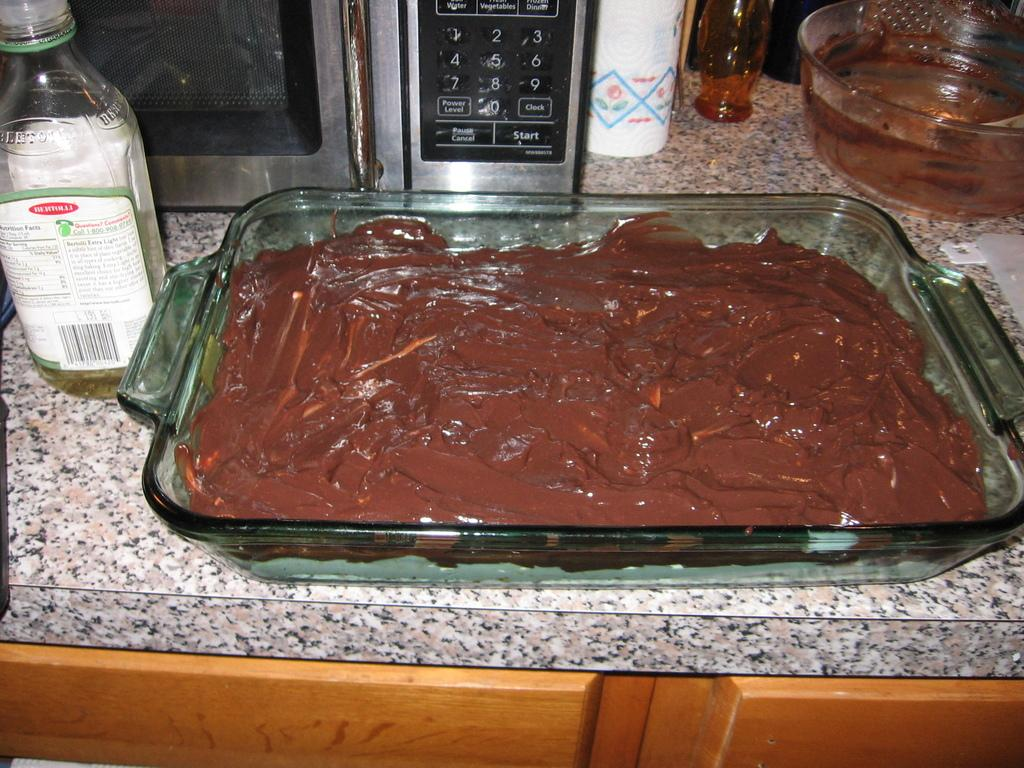What is the main subject in the center of the image? There is a food item and a bottle in the center of the image. What type of appliance can be seen in the image? There is a microwave in the in the image. Can you describe any other objects present in the image? There are some objects in the image. How does the kitty show respect to the food item in the image? There is no kitty present in the image, so it cannot show respect or interact with the food item in any way. 